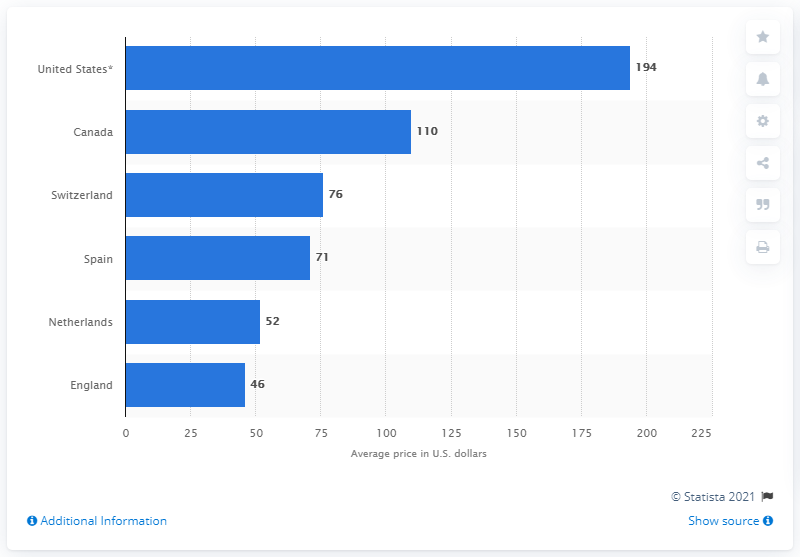Highlight a few significant elements in this photo. In 2013, the average price of Cymbalta in the Netherlands was 52. 